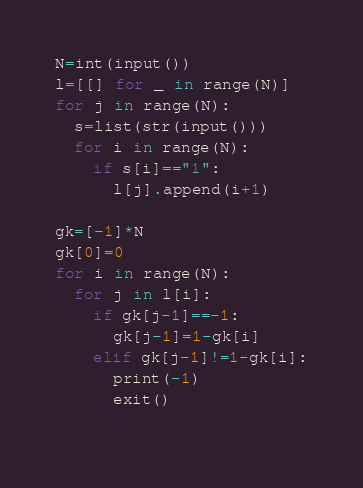Convert code to text. <code><loc_0><loc_0><loc_500><loc_500><_Python_>N=int(input())
l=[[] for _ in range(N)]
for j in range(N):
  s=list(str(input()))
  for i in range(N):
    if s[i]=="1":
      l[j].append(i+1)
      
gk=[-1]*N
gk[0]=0
for i in range(N):
  for j in l[i]:
    if gk[j-1]==-1:
      gk[j-1]=1-gk[i]
    elif gk[j-1]!=1-gk[i]:
      print(-1)
      exit()
      

</code> 